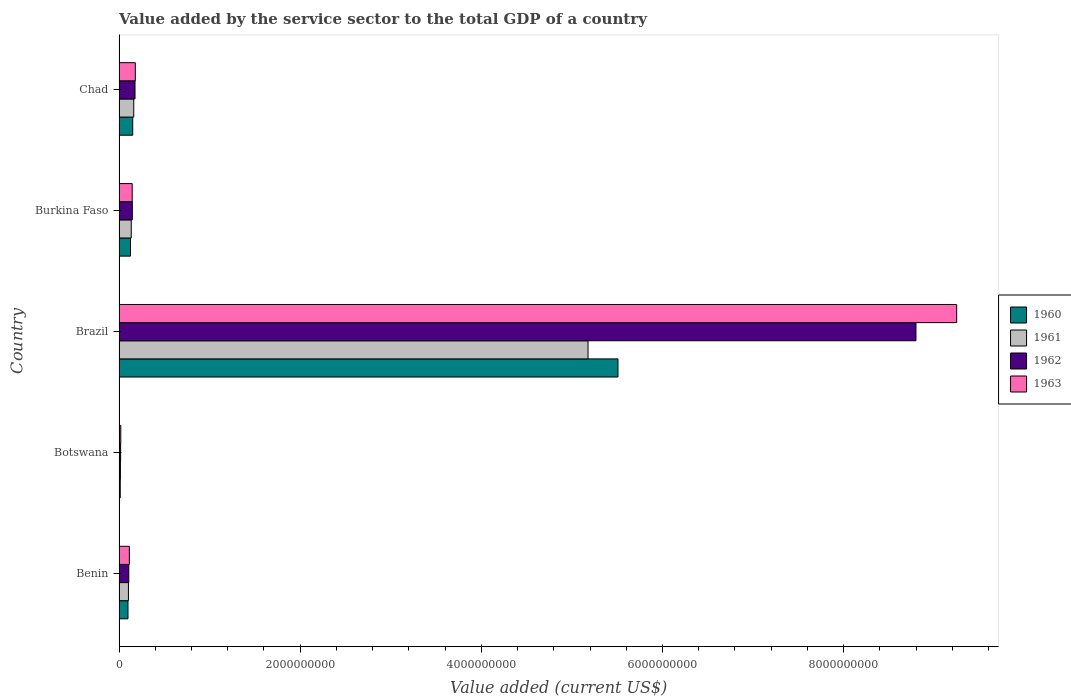How many groups of bars are there?
Ensure brevity in your answer.  5. Are the number of bars per tick equal to the number of legend labels?
Your answer should be compact. Yes. What is the label of the 2nd group of bars from the top?
Keep it short and to the point. Burkina Faso. In how many cases, is the number of bars for a given country not equal to the number of legend labels?
Your answer should be compact. 0. What is the value added by the service sector to the total GDP in 1961 in Brazil?
Your response must be concise. 5.18e+09. Across all countries, what is the maximum value added by the service sector to the total GDP in 1961?
Ensure brevity in your answer.  5.18e+09. Across all countries, what is the minimum value added by the service sector to the total GDP in 1963?
Your answer should be compact. 1.93e+07. In which country was the value added by the service sector to the total GDP in 1962 minimum?
Offer a very short reply. Botswana. What is the total value added by the service sector to the total GDP in 1960 in the graph?
Keep it short and to the point. 5.90e+09. What is the difference between the value added by the service sector to the total GDP in 1960 in Brazil and that in Chad?
Offer a terse response. 5.36e+09. What is the difference between the value added by the service sector to the total GDP in 1963 in Brazil and the value added by the service sector to the total GDP in 1961 in Benin?
Your response must be concise. 9.14e+09. What is the average value added by the service sector to the total GDP in 1960 per country?
Provide a short and direct response. 1.18e+09. What is the difference between the value added by the service sector to the total GDP in 1961 and value added by the service sector to the total GDP in 1962 in Brazil?
Offer a very short reply. -3.62e+09. What is the ratio of the value added by the service sector to the total GDP in 1962 in Botswana to that in Brazil?
Ensure brevity in your answer.  0. Is the value added by the service sector to the total GDP in 1963 in Benin less than that in Burkina Faso?
Offer a very short reply. Yes. What is the difference between the highest and the second highest value added by the service sector to the total GDP in 1960?
Keep it short and to the point. 5.36e+09. What is the difference between the highest and the lowest value added by the service sector to the total GDP in 1960?
Offer a very short reply. 5.50e+09. In how many countries, is the value added by the service sector to the total GDP in 1960 greater than the average value added by the service sector to the total GDP in 1960 taken over all countries?
Give a very brief answer. 1. Is the sum of the value added by the service sector to the total GDP in 1961 in Benin and Burkina Faso greater than the maximum value added by the service sector to the total GDP in 1960 across all countries?
Provide a succinct answer. No. What does the 3rd bar from the bottom in Brazil represents?
Provide a succinct answer. 1962. How many bars are there?
Provide a short and direct response. 20. Are the values on the major ticks of X-axis written in scientific E-notation?
Provide a succinct answer. No. Does the graph contain any zero values?
Keep it short and to the point. No. Does the graph contain grids?
Offer a terse response. No. How are the legend labels stacked?
Your answer should be compact. Vertical. What is the title of the graph?
Your answer should be compact. Value added by the service sector to the total GDP of a country. What is the label or title of the X-axis?
Your answer should be compact. Value added (current US$). What is the label or title of the Y-axis?
Make the answer very short. Country. What is the Value added (current US$) of 1960 in Benin?
Provide a succinct answer. 9.87e+07. What is the Value added (current US$) of 1961 in Benin?
Ensure brevity in your answer.  1.04e+08. What is the Value added (current US$) in 1962 in Benin?
Provide a short and direct response. 1.08e+08. What is the Value added (current US$) of 1963 in Benin?
Your answer should be compact. 1.14e+08. What is the Value added (current US$) of 1960 in Botswana?
Keep it short and to the point. 1.31e+07. What is the Value added (current US$) of 1961 in Botswana?
Offer a terse response. 1.51e+07. What is the Value added (current US$) in 1962 in Botswana?
Provide a succinct answer. 1.73e+07. What is the Value added (current US$) of 1963 in Botswana?
Give a very brief answer. 1.93e+07. What is the Value added (current US$) of 1960 in Brazil?
Your response must be concise. 5.51e+09. What is the Value added (current US$) in 1961 in Brazil?
Offer a very short reply. 5.18e+09. What is the Value added (current US$) of 1962 in Brazil?
Ensure brevity in your answer.  8.80e+09. What is the Value added (current US$) of 1963 in Brazil?
Your response must be concise. 9.25e+09. What is the Value added (current US$) of 1960 in Burkina Faso?
Keep it short and to the point. 1.26e+08. What is the Value added (current US$) in 1961 in Burkina Faso?
Offer a very short reply. 1.35e+08. What is the Value added (current US$) in 1962 in Burkina Faso?
Provide a succinct answer. 1.47e+08. What is the Value added (current US$) in 1963 in Burkina Faso?
Give a very brief answer. 1.45e+08. What is the Value added (current US$) of 1960 in Chad?
Provide a short and direct response. 1.51e+08. What is the Value added (current US$) in 1961 in Chad?
Provide a short and direct response. 1.62e+08. What is the Value added (current US$) of 1962 in Chad?
Offer a very short reply. 1.76e+08. What is the Value added (current US$) of 1963 in Chad?
Give a very brief answer. 1.80e+08. Across all countries, what is the maximum Value added (current US$) in 1960?
Give a very brief answer. 5.51e+09. Across all countries, what is the maximum Value added (current US$) in 1961?
Provide a succinct answer. 5.18e+09. Across all countries, what is the maximum Value added (current US$) of 1962?
Keep it short and to the point. 8.80e+09. Across all countries, what is the maximum Value added (current US$) in 1963?
Provide a succinct answer. 9.25e+09. Across all countries, what is the minimum Value added (current US$) in 1960?
Provide a short and direct response. 1.31e+07. Across all countries, what is the minimum Value added (current US$) of 1961?
Your answer should be compact. 1.51e+07. Across all countries, what is the minimum Value added (current US$) of 1962?
Provide a succinct answer. 1.73e+07. Across all countries, what is the minimum Value added (current US$) of 1963?
Your answer should be very brief. 1.93e+07. What is the total Value added (current US$) of 1960 in the graph?
Ensure brevity in your answer.  5.90e+09. What is the total Value added (current US$) of 1961 in the graph?
Keep it short and to the point. 5.59e+09. What is the total Value added (current US$) in 1962 in the graph?
Give a very brief answer. 9.25e+09. What is the total Value added (current US$) in 1963 in the graph?
Your answer should be very brief. 9.71e+09. What is the difference between the Value added (current US$) in 1960 in Benin and that in Botswana?
Give a very brief answer. 8.55e+07. What is the difference between the Value added (current US$) of 1961 in Benin and that in Botswana?
Offer a very short reply. 8.86e+07. What is the difference between the Value added (current US$) of 1962 in Benin and that in Botswana?
Your answer should be very brief. 9.03e+07. What is the difference between the Value added (current US$) in 1963 in Benin and that in Botswana?
Make the answer very short. 9.45e+07. What is the difference between the Value added (current US$) of 1960 in Benin and that in Brazil?
Provide a short and direct response. -5.41e+09. What is the difference between the Value added (current US$) of 1961 in Benin and that in Brazil?
Your answer should be very brief. -5.07e+09. What is the difference between the Value added (current US$) of 1962 in Benin and that in Brazil?
Provide a succinct answer. -8.69e+09. What is the difference between the Value added (current US$) in 1963 in Benin and that in Brazil?
Provide a short and direct response. -9.13e+09. What is the difference between the Value added (current US$) of 1960 in Benin and that in Burkina Faso?
Provide a short and direct response. -2.78e+07. What is the difference between the Value added (current US$) of 1961 in Benin and that in Burkina Faso?
Provide a short and direct response. -3.11e+07. What is the difference between the Value added (current US$) in 1962 in Benin and that in Burkina Faso?
Offer a terse response. -3.91e+07. What is the difference between the Value added (current US$) in 1963 in Benin and that in Burkina Faso?
Give a very brief answer. -3.15e+07. What is the difference between the Value added (current US$) in 1960 in Benin and that in Chad?
Offer a very short reply. -5.23e+07. What is the difference between the Value added (current US$) of 1961 in Benin and that in Chad?
Make the answer very short. -5.88e+07. What is the difference between the Value added (current US$) in 1962 in Benin and that in Chad?
Ensure brevity in your answer.  -6.87e+07. What is the difference between the Value added (current US$) of 1963 in Benin and that in Chad?
Your answer should be very brief. -6.58e+07. What is the difference between the Value added (current US$) of 1960 in Botswana and that in Brazil?
Provide a short and direct response. -5.50e+09. What is the difference between the Value added (current US$) of 1961 in Botswana and that in Brazil?
Provide a succinct answer. -5.16e+09. What is the difference between the Value added (current US$) in 1962 in Botswana and that in Brazil?
Keep it short and to the point. -8.78e+09. What is the difference between the Value added (current US$) in 1963 in Botswana and that in Brazil?
Keep it short and to the point. -9.23e+09. What is the difference between the Value added (current US$) in 1960 in Botswana and that in Burkina Faso?
Provide a succinct answer. -1.13e+08. What is the difference between the Value added (current US$) of 1961 in Botswana and that in Burkina Faso?
Give a very brief answer. -1.20e+08. What is the difference between the Value added (current US$) of 1962 in Botswana and that in Burkina Faso?
Offer a very short reply. -1.29e+08. What is the difference between the Value added (current US$) in 1963 in Botswana and that in Burkina Faso?
Offer a very short reply. -1.26e+08. What is the difference between the Value added (current US$) in 1960 in Botswana and that in Chad?
Keep it short and to the point. -1.38e+08. What is the difference between the Value added (current US$) in 1961 in Botswana and that in Chad?
Keep it short and to the point. -1.47e+08. What is the difference between the Value added (current US$) in 1962 in Botswana and that in Chad?
Provide a short and direct response. -1.59e+08. What is the difference between the Value added (current US$) of 1963 in Botswana and that in Chad?
Ensure brevity in your answer.  -1.60e+08. What is the difference between the Value added (current US$) in 1960 in Brazil and that in Burkina Faso?
Your answer should be very brief. 5.38e+09. What is the difference between the Value added (current US$) of 1961 in Brazil and that in Burkina Faso?
Your response must be concise. 5.04e+09. What is the difference between the Value added (current US$) in 1962 in Brazil and that in Burkina Faso?
Your answer should be compact. 8.65e+09. What is the difference between the Value added (current US$) in 1963 in Brazil and that in Burkina Faso?
Keep it short and to the point. 9.10e+09. What is the difference between the Value added (current US$) in 1960 in Brazil and that in Chad?
Ensure brevity in your answer.  5.36e+09. What is the difference between the Value added (current US$) in 1961 in Brazil and that in Chad?
Ensure brevity in your answer.  5.02e+09. What is the difference between the Value added (current US$) in 1962 in Brazil and that in Chad?
Your response must be concise. 8.62e+09. What is the difference between the Value added (current US$) in 1963 in Brazil and that in Chad?
Your response must be concise. 9.07e+09. What is the difference between the Value added (current US$) in 1960 in Burkina Faso and that in Chad?
Make the answer very short. -2.45e+07. What is the difference between the Value added (current US$) in 1961 in Burkina Faso and that in Chad?
Make the answer very short. -2.77e+07. What is the difference between the Value added (current US$) in 1962 in Burkina Faso and that in Chad?
Your response must be concise. -2.96e+07. What is the difference between the Value added (current US$) of 1963 in Burkina Faso and that in Chad?
Offer a very short reply. -3.43e+07. What is the difference between the Value added (current US$) in 1960 in Benin and the Value added (current US$) in 1961 in Botswana?
Provide a short and direct response. 8.36e+07. What is the difference between the Value added (current US$) in 1960 in Benin and the Value added (current US$) in 1962 in Botswana?
Your response must be concise. 8.14e+07. What is the difference between the Value added (current US$) of 1960 in Benin and the Value added (current US$) of 1963 in Botswana?
Your answer should be very brief. 7.94e+07. What is the difference between the Value added (current US$) in 1961 in Benin and the Value added (current US$) in 1962 in Botswana?
Make the answer very short. 8.64e+07. What is the difference between the Value added (current US$) of 1961 in Benin and the Value added (current US$) of 1963 in Botswana?
Provide a short and direct response. 8.44e+07. What is the difference between the Value added (current US$) in 1962 in Benin and the Value added (current US$) in 1963 in Botswana?
Give a very brief answer. 8.83e+07. What is the difference between the Value added (current US$) of 1960 in Benin and the Value added (current US$) of 1961 in Brazil?
Make the answer very short. -5.08e+09. What is the difference between the Value added (current US$) in 1960 in Benin and the Value added (current US$) in 1962 in Brazil?
Make the answer very short. -8.70e+09. What is the difference between the Value added (current US$) of 1960 in Benin and the Value added (current US$) of 1963 in Brazil?
Offer a very short reply. -9.15e+09. What is the difference between the Value added (current US$) in 1961 in Benin and the Value added (current US$) in 1962 in Brazil?
Your answer should be compact. -8.70e+09. What is the difference between the Value added (current US$) in 1961 in Benin and the Value added (current US$) in 1963 in Brazil?
Your response must be concise. -9.14e+09. What is the difference between the Value added (current US$) in 1962 in Benin and the Value added (current US$) in 1963 in Brazil?
Make the answer very short. -9.14e+09. What is the difference between the Value added (current US$) of 1960 in Benin and the Value added (current US$) of 1961 in Burkina Faso?
Keep it short and to the point. -3.61e+07. What is the difference between the Value added (current US$) of 1960 in Benin and the Value added (current US$) of 1962 in Burkina Faso?
Give a very brief answer. -4.81e+07. What is the difference between the Value added (current US$) of 1960 in Benin and the Value added (current US$) of 1963 in Burkina Faso?
Provide a succinct answer. -4.67e+07. What is the difference between the Value added (current US$) in 1961 in Benin and the Value added (current US$) in 1962 in Burkina Faso?
Ensure brevity in your answer.  -4.30e+07. What is the difference between the Value added (current US$) in 1961 in Benin and the Value added (current US$) in 1963 in Burkina Faso?
Keep it short and to the point. -4.16e+07. What is the difference between the Value added (current US$) of 1962 in Benin and the Value added (current US$) of 1963 in Burkina Faso?
Provide a succinct answer. -3.77e+07. What is the difference between the Value added (current US$) in 1960 in Benin and the Value added (current US$) in 1961 in Chad?
Provide a succinct answer. -6.38e+07. What is the difference between the Value added (current US$) of 1960 in Benin and the Value added (current US$) of 1962 in Chad?
Ensure brevity in your answer.  -7.76e+07. What is the difference between the Value added (current US$) in 1960 in Benin and the Value added (current US$) in 1963 in Chad?
Offer a very short reply. -8.10e+07. What is the difference between the Value added (current US$) of 1961 in Benin and the Value added (current US$) of 1962 in Chad?
Your response must be concise. -7.26e+07. What is the difference between the Value added (current US$) in 1961 in Benin and the Value added (current US$) in 1963 in Chad?
Provide a succinct answer. -7.59e+07. What is the difference between the Value added (current US$) of 1962 in Benin and the Value added (current US$) of 1963 in Chad?
Keep it short and to the point. -7.20e+07. What is the difference between the Value added (current US$) in 1960 in Botswana and the Value added (current US$) in 1961 in Brazil?
Make the answer very short. -5.17e+09. What is the difference between the Value added (current US$) in 1960 in Botswana and the Value added (current US$) in 1962 in Brazil?
Provide a short and direct response. -8.79e+09. What is the difference between the Value added (current US$) of 1960 in Botswana and the Value added (current US$) of 1963 in Brazil?
Keep it short and to the point. -9.24e+09. What is the difference between the Value added (current US$) in 1961 in Botswana and the Value added (current US$) in 1962 in Brazil?
Your answer should be compact. -8.78e+09. What is the difference between the Value added (current US$) of 1961 in Botswana and the Value added (current US$) of 1963 in Brazil?
Your answer should be compact. -9.23e+09. What is the difference between the Value added (current US$) of 1962 in Botswana and the Value added (current US$) of 1963 in Brazil?
Your answer should be very brief. -9.23e+09. What is the difference between the Value added (current US$) in 1960 in Botswana and the Value added (current US$) in 1961 in Burkina Faso?
Provide a short and direct response. -1.22e+08. What is the difference between the Value added (current US$) in 1960 in Botswana and the Value added (current US$) in 1962 in Burkina Faso?
Offer a terse response. -1.34e+08. What is the difference between the Value added (current US$) in 1960 in Botswana and the Value added (current US$) in 1963 in Burkina Faso?
Your answer should be very brief. -1.32e+08. What is the difference between the Value added (current US$) of 1961 in Botswana and the Value added (current US$) of 1962 in Burkina Faso?
Your answer should be compact. -1.32e+08. What is the difference between the Value added (current US$) in 1961 in Botswana and the Value added (current US$) in 1963 in Burkina Faso?
Provide a succinct answer. -1.30e+08. What is the difference between the Value added (current US$) in 1962 in Botswana and the Value added (current US$) in 1963 in Burkina Faso?
Keep it short and to the point. -1.28e+08. What is the difference between the Value added (current US$) in 1960 in Botswana and the Value added (current US$) in 1961 in Chad?
Make the answer very short. -1.49e+08. What is the difference between the Value added (current US$) in 1960 in Botswana and the Value added (current US$) in 1962 in Chad?
Offer a very short reply. -1.63e+08. What is the difference between the Value added (current US$) of 1960 in Botswana and the Value added (current US$) of 1963 in Chad?
Provide a short and direct response. -1.67e+08. What is the difference between the Value added (current US$) of 1961 in Botswana and the Value added (current US$) of 1962 in Chad?
Offer a terse response. -1.61e+08. What is the difference between the Value added (current US$) of 1961 in Botswana and the Value added (current US$) of 1963 in Chad?
Your response must be concise. -1.65e+08. What is the difference between the Value added (current US$) in 1962 in Botswana and the Value added (current US$) in 1963 in Chad?
Your answer should be compact. -1.62e+08. What is the difference between the Value added (current US$) of 1960 in Brazil and the Value added (current US$) of 1961 in Burkina Faso?
Ensure brevity in your answer.  5.37e+09. What is the difference between the Value added (current US$) of 1960 in Brazil and the Value added (current US$) of 1962 in Burkina Faso?
Give a very brief answer. 5.36e+09. What is the difference between the Value added (current US$) in 1960 in Brazil and the Value added (current US$) in 1963 in Burkina Faso?
Keep it short and to the point. 5.36e+09. What is the difference between the Value added (current US$) in 1961 in Brazil and the Value added (current US$) in 1962 in Burkina Faso?
Give a very brief answer. 5.03e+09. What is the difference between the Value added (current US$) of 1961 in Brazil and the Value added (current US$) of 1963 in Burkina Faso?
Your answer should be compact. 5.03e+09. What is the difference between the Value added (current US$) in 1962 in Brazil and the Value added (current US$) in 1963 in Burkina Faso?
Your answer should be compact. 8.65e+09. What is the difference between the Value added (current US$) in 1960 in Brazil and the Value added (current US$) in 1961 in Chad?
Your response must be concise. 5.35e+09. What is the difference between the Value added (current US$) of 1960 in Brazil and the Value added (current US$) of 1962 in Chad?
Make the answer very short. 5.33e+09. What is the difference between the Value added (current US$) in 1960 in Brazil and the Value added (current US$) in 1963 in Chad?
Your answer should be compact. 5.33e+09. What is the difference between the Value added (current US$) in 1961 in Brazil and the Value added (current US$) in 1962 in Chad?
Offer a very short reply. 5.00e+09. What is the difference between the Value added (current US$) in 1961 in Brazil and the Value added (current US$) in 1963 in Chad?
Provide a succinct answer. 5.00e+09. What is the difference between the Value added (current US$) of 1962 in Brazil and the Value added (current US$) of 1963 in Chad?
Ensure brevity in your answer.  8.62e+09. What is the difference between the Value added (current US$) in 1960 in Burkina Faso and the Value added (current US$) in 1961 in Chad?
Keep it short and to the point. -3.60e+07. What is the difference between the Value added (current US$) in 1960 in Burkina Faso and the Value added (current US$) in 1962 in Chad?
Your response must be concise. -4.98e+07. What is the difference between the Value added (current US$) in 1960 in Burkina Faso and the Value added (current US$) in 1963 in Chad?
Make the answer very short. -5.32e+07. What is the difference between the Value added (current US$) of 1961 in Burkina Faso and the Value added (current US$) of 1962 in Chad?
Give a very brief answer. -4.15e+07. What is the difference between the Value added (current US$) in 1961 in Burkina Faso and the Value added (current US$) in 1963 in Chad?
Ensure brevity in your answer.  -4.49e+07. What is the difference between the Value added (current US$) in 1962 in Burkina Faso and the Value added (current US$) in 1963 in Chad?
Provide a short and direct response. -3.29e+07. What is the average Value added (current US$) in 1960 per country?
Make the answer very short. 1.18e+09. What is the average Value added (current US$) of 1961 per country?
Keep it short and to the point. 1.12e+09. What is the average Value added (current US$) of 1962 per country?
Ensure brevity in your answer.  1.85e+09. What is the average Value added (current US$) of 1963 per country?
Your response must be concise. 1.94e+09. What is the difference between the Value added (current US$) of 1960 and Value added (current US$) of 1961 in Benin?
Make the answer very short. -5.02e+06. What is the difference between the Value added (current US$) of 1960 and Value added (current US$) of 1962 in Benin?
Give a very brief answer. -8.92e+06. What is the difference between the Value added (current US$) of 1960 and Value added (current US$) of 1963 in Benin?
Your answer should be compact. -1.51e+07. What is the difference between the Value added (current US$) in 1961 and Value added (current US$) in 1962 in Benin?
Make the answer very short. -3.90e+06. What is the difference between the Value added (current US$) of 1961 and Value added (current US$) of 1963 in Benin?
Make the answer very short. -1.01e+07. What is the difference between the Value added (current US$) of 1962 and Value added (current US$) of 1963 in Benin?
Make the answer very short. -6.21e+06. What is the difference between the Value added (current US$) in 1960 and Value added (current US$) in 1961 in Botswana?
Provide a succinct answer. -1.99e+06. What is the difference between the Value added (current US$) of 1960 and Value added (current US$) of 1962 in Botswana?
Provide a short and direct response. -4.17e+06. What is the difference between the Value added (current US$) in 1960 and Value added (current US$) in 1963 in Botswana?
Keep it short and to the point. -6.14e+06. What is the difference between the Value added (current US$) of 1961 and Value added (current US$) of 1962 in Botswana?
Give a very brief answer. -2.18e+06. What is the difference between the Value added (current US$) of 1961 and Value added (current US$) of 1963 in Botswana?
Give a very brief answer. -4.15e+06. What is the difference between the Value added (current US$) of 1962 and Value added (current US$) of 1963 in Botswana?
Offer a terse response. -1.97e+06. What is the difference between the Value added (current US$) in 1960 and Value added (current US$) in 1961 in Brazil?
Offer a terse response. 3.31e+08. What is the difference between the Value added (current US$) in 1960 and Value added (current US$) in 1962 in Brazil?
Provide a short and direct response. -3.29e+09. What is the difference between the Value added (current US$) of 1960 and Value added (current US$) of 1963 in Brazil?
Provide a short and direct response. -3.74e+09. What is the difference between the Value added (current US$) of 1961 and Value added (current US$) of 1962 in Brazil?
Your response must be concise. -3.62e+09. What is the difference between the Value added (current US$) of 1961 and Value added (current US$) of 1963 in Brazil?
Keep it short and to the point. -4.07e+09. What is the difference between the Value added (current US$) of 1962 and Value added (current US$) of 1963 in Brazil?
Give a very brief answer. -4.49e+08. What is the difference between the Value added (current US$) of 1960 and Value added (current US$) of 1961 in Burkina Faso?
Make the answer very short. -8.32e+06. What is the difference between the Value added (current US$) of 1960 and Value added (current US$) of 1962 in Burkina Faso?
Your answer should be very brief. -2.03e+07. What is the difference between the Value added (current US$) in 1960 and Value added (current US$) in 1963 in Burkina Faso?
Your answer should be very brief. -1.89e+07. What is the difference between the Value added (current US$) in 1961 and Value added (current US$) in 1962 in Burkina Faso?
Offer a terse response. -1.19e+07. What is the difference between the Value added (current US$) in 1961 and Value added (current US$) in 1963 in Burkina Faso?
Make the answer very short. -1.06e+07. What is the difference between the Value added (current US$) of 1962 and Value added (current US$) of 1963 in Burkina Faso?
Provide a succinct answer. 1.38e+06. What is the difference between the Value added (current US$) of 1960 and Value added (current US$) of 1961 in Chad?
Ensure brevity in your answer.  -1.15e+07. What is the difference between the Value added (current US$) in 1960 and Value added (current US$) in 1962 in Chad?
Your answer should be compact. -2.53e+07. What is the difference between the Value added (current US$) in 1960 and Value added (current US$) in 1963 in Chad?
Your answer should be very brief. -2.87e+07. What is the difference between the Value added (current US$) of 1961 and Value added (current US$) of 1962 in Chad?
Give a very brief answer. -1.38e+07. What is the difference between the Value added (current US$) in 1961 and Value added (current US$) in 1963 in Chad?
Make the answer very short. -1.71e+07. What is the difference between the Value added (current US$) of 1962 and Value added (current US$) of 1963 in Chad?
Make the answer very short. -3.34e+06. What is the ratio of the Value added (current US$) in 1960 in Benin to that in Botswana?
Ensure brevity in your answer.  7.52. What is the ratio of the Value added (current US$) of 1961 in Benin to that in Botswana?
Offer a terse response. 6.86. What is the ratio of the Value added (current US$) in 1962 in Benin to that in Botswana?
Provide a short and direct response. 6.22. What is the ratio of the Value added (current US$) in 1963 in Benin to that in Botswana?
Provide a succinct answer. 5.91. What is the ratio of the Value added (current US$) in 1960 in Benin to that in Brazil?
Make the answer very short. 0.02. What is the ratio of the Value added (current US$) of 1962 in Benin to that in Brazil?
Give a very brief answer. 0.01. What is the ratio of the Value added (current US$) in 1963 in Benin to that in Brazil?
Ensure brevity in your answer.  0.01. What is the ratio of the Value added (current US$) in 1960 in Benin to that in Burkina Faso?
Ensure brevity in your answer.  0.78. What is the ratio of the Value added (current US$) of 1961 in Benin to that in Burkina Faso?
Give a very brief answer. 0.77. What is the ratio of the Value added (current US$) in 1962 in Benin to that in Burkina Faso?
Give a very brief answer. 0.73. What is the ratio of the Value added (current US$) in 1963 in Benin to that in Burkina Faso?
Offer a terse response. 0.78. What is the ratio of the Value added (current US$) of 1960 in Benin to that in Chad?
Offer a terse response. 0.65. What is the ratio of the Value added (current US$) in 1961 in Benin to that in Chad?
Offer a terse response. 0.64. What is the ratio of the Value added (current US$) of 1962 in Benin to that in Chad?
Your answer should be very brief. 0.61. What is the ratio of the Value added (current US$) of 1963 in Benin to that in Chad?
Offer a terse response. 0.63. What is the ratio of the Value added (current US$) of 1960 in Botswana to that in Brazil?
Provide a short and direct response. 0. What is the ratio of the Value added (current US$) of 1961 in Botswana to that in Brazil?
Ensure brevity in your answer.  0. What is the ratio of the Value added (current US$) of 1962 in Botswana to that in Brazil?
Ensure brevity in your answer.  0. What is the ratio of the Value added (current US$) in 1963 in Botswana to that in Brazil?
Make the answer very short. 0. What is the ratio of the Value added (current US$) of 1960 in Botswana to that in Burkina Faso?
Your answer should be very brief. 0.1. What is the ratio of the Value added (current US$) in 1961 in Botswana to that in Burkina Faso?
Offer a terse response. 0.11. What is the ratio of the Value added (current US$) of 1962 in Botswana to that in Burkina Faso?
Your answer should be compact. 0.12. What is the ratio of the Value added (current US$) of 1963 in Botswana to that in Burkina Faso?
Offer a terse response. 0.13. What is the ratio of the Value added (current US$) of 1960 in Botswana to that in Chad?
Make the answer very short. 0.09. What is the ratio of the Value added (current US$) of 1961 in Botswana to that in Chad?
Ensure brevity in your answer.  0.09. What is the ratio of the Value added (current US$) in 1962 in Botswana to that in Chad?
Make the answer very short. 0.1. What is the ratio of the Value added (current US$) of 1963 in Botswana to that in Chad?
Give a very brief answer. 0.11. What is the ratio of the Value added (current US$) of 1960 in Brazil to that in Burkina Faso?
Provide a succinct answer. 43.57. What is the ratio of the Value added (current US$) in 1961 in Brazil to that in Burkina Faso?
Provide a succinct answer. 38.42. What is the ratio of the Value added (current US$) in 1962 in Brazil to that in Burkina Faso?
Your answer should be compact. 59.98. What is the ratio of the Value added (current US$) of 1963 in Brazil to that in Burkina Faso?
Provide a short and direct response. 63.64. What is the ratio of the Value added (current US$) of 1960 in Brazil to that in Chad?
Make the answer very short. 36.49. What is the ratio of the Value added (current US$) of 1961 in Brazil to that in Chad?
Offer a terse response. 31.87. What is the ratio of the Value added (current US$) in 1962 in Brazil to that in Chad?
Offer a very short reply. 49.91. What is the ratio of the Value added (current US$) of 1963 in Brazil to that in Chad?
Provide a short and direct response. 51.49. What is the ratio of the Value added (current US$) of 1960 in Burkina Faso to that in Chad?
Provide a succinct answer. 0.84. What is the ratio of the Value added (current US$) of 1961 in Burkina Faso to that in Chad?
Your answer should be very brief. 0.83. What is the ratio of the Value added (current US$) of 1962 in Burkina Faso to that in Chad?
Ensure brevity in your answer.  0.83. What is the ratio of the Value added (current US$) in 1963 in Burkina Faso to that in Chad?
Give a very brief answer. 0.81. What is the difference between the highest and the second highest Value added (current US$) of 1960?
Your answer should be compact. 5.36e+09. What is the difference between the highest and the second highest Value added (current US$) in 1961?
Offer a terse response. 5.02e+09. What is the difference between the highest and the second highest Value added (current US$) in 1962?
Your answer should be very brief. 8.62e+09. What is the difference between the highest and the second highest Value added (current US$) of 1963?
Provide a short and direct response. 9.07e+09. What is the difference between the highest and the lowest Value added (current US$) of 1960?
Provide a short and direct response. 5.50e+09. What is the difference between the highest and the lowest Value added (current US$) of 1961?
Your answer should be very brief. 5.16e+09. What is the difference between the highest and the lowest Value added (current US$) in 1962?
Your answer should be compact. 8.78e+09. What is the difference between the highest and the lowest Value added (current US$) in 1963?
Offer a very short reply. 9.23e+09. 